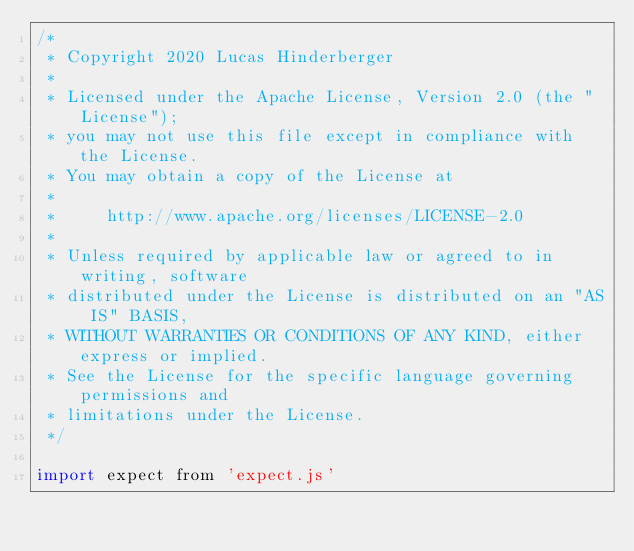Convert code to text. <code><loc_0><loc_0><loc_500><loc_500><_JavaScript_>/*
 * Copyright 2020 Lucas Hinderberger
 *
 * Licensed under the Apache License, Version 2.0 (the "License");
 * you may not use this file except in compliance with the License.
 * You may obtain a copy of the License at
 *
 *     http://www.apache.org/licenses/LICENSE-2.0
 *
 * Unless required by applicable law or agreed to in writing, software
 * distributed under the License is distributed on an "AS IS" BASIS,
 * WITHOUT WARRANTIES OR CONDITIONS OF ANY KIND, either express or implied.
 * See the License for the specific language governing permissions and
 * limitations under the License.
 */

import expect from 'expect.js'</code> 